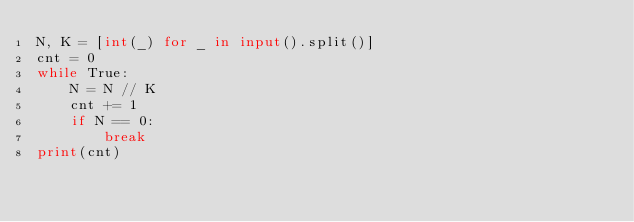<code> <loc_0><loc_0><loc_500><loc_500><_Python_>N, K = [int(_) for _ in input().split()]
cnt = 0
while True:
    N = N // K
    cnt += 1
    if N == 0:
        break
print(cnt)
</code> 